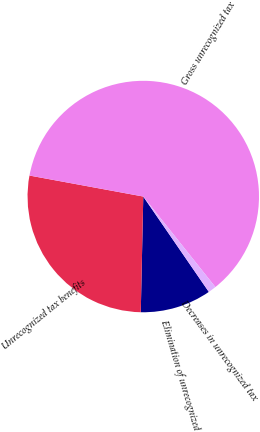Convert chart. <chart><loc_0><loc_0><loc_500><loc_500><pie_chart><fcel>Elimination of unrecognized<fcel>Unrecognized tax benefits<fcel>Gross unrecognized tax<fcel>Decreases in unrecognized tax<nl><fcel>9.93%<fcel>27.56%<fcel>61.39%<fcel>1.12%<nl></chart> 